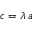Convert formula to latex. <formula><loc_0><loc_0><loc_500><loc_500>c = \lambda \, a</formula> 